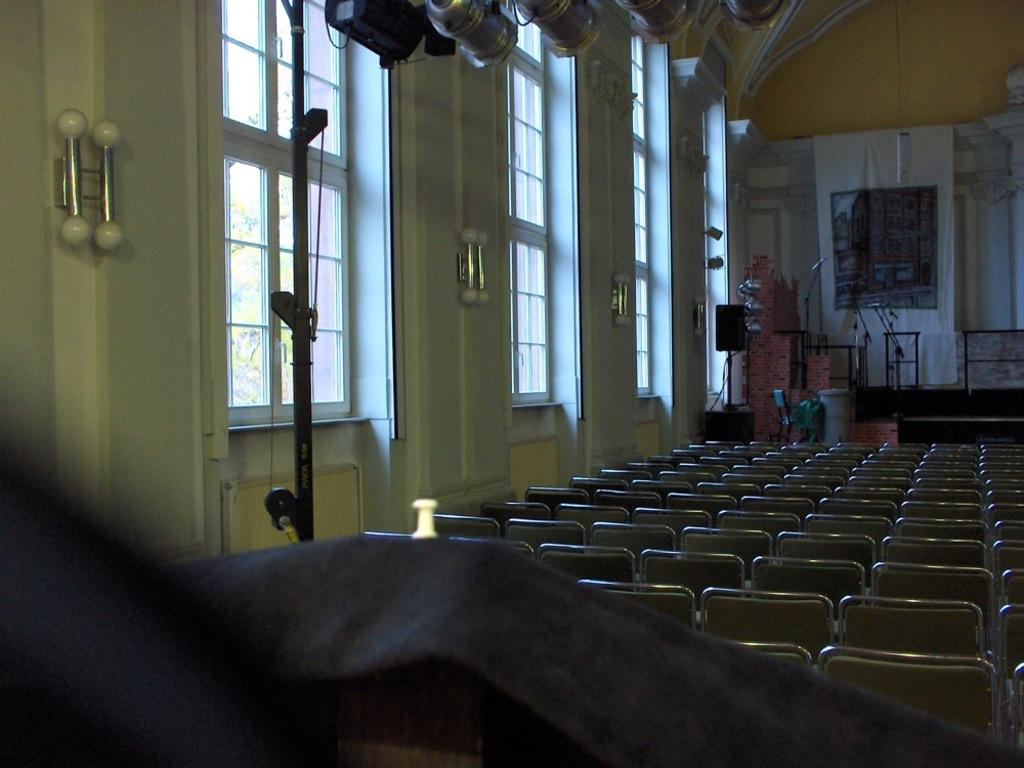What type of setting is depicted in the image? The image is an inside view of a building. What type of furniture is visible in the image? There are many chairs visible in the image. What type of illumination is present in the image? There are lights visible in the image. What type of knee injury can be seen in the image? There is no knee injury present in the image. What type of skin condition can be seen on the people in the image? There are no people visible in the image, so it is not possible to determine if any have a skin condition. 